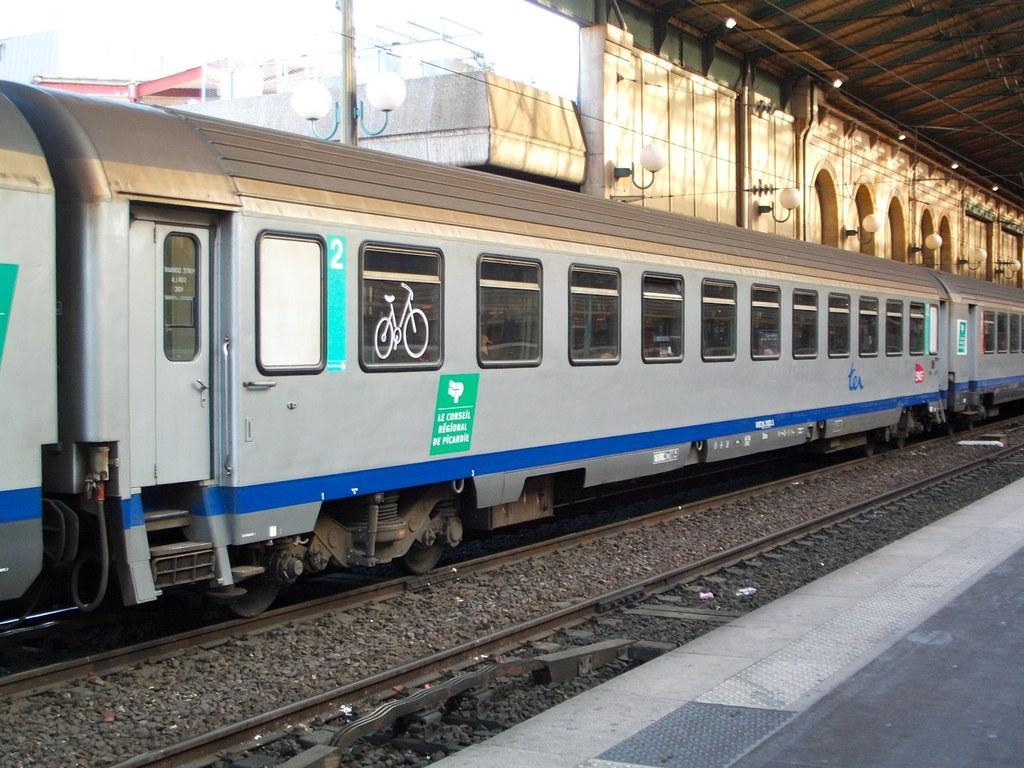Can you describe this image briefly? In this image we can see a train on the track, there are some lights and a building, also we can see the railway platform. 